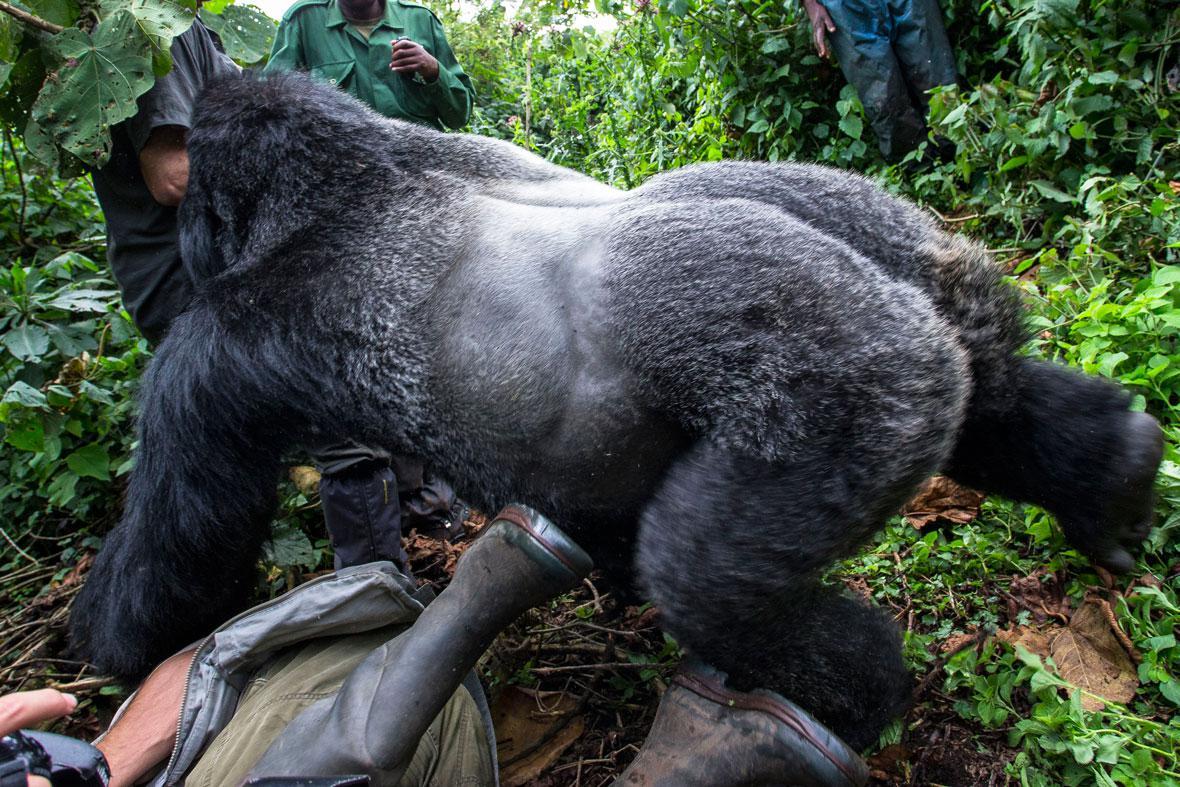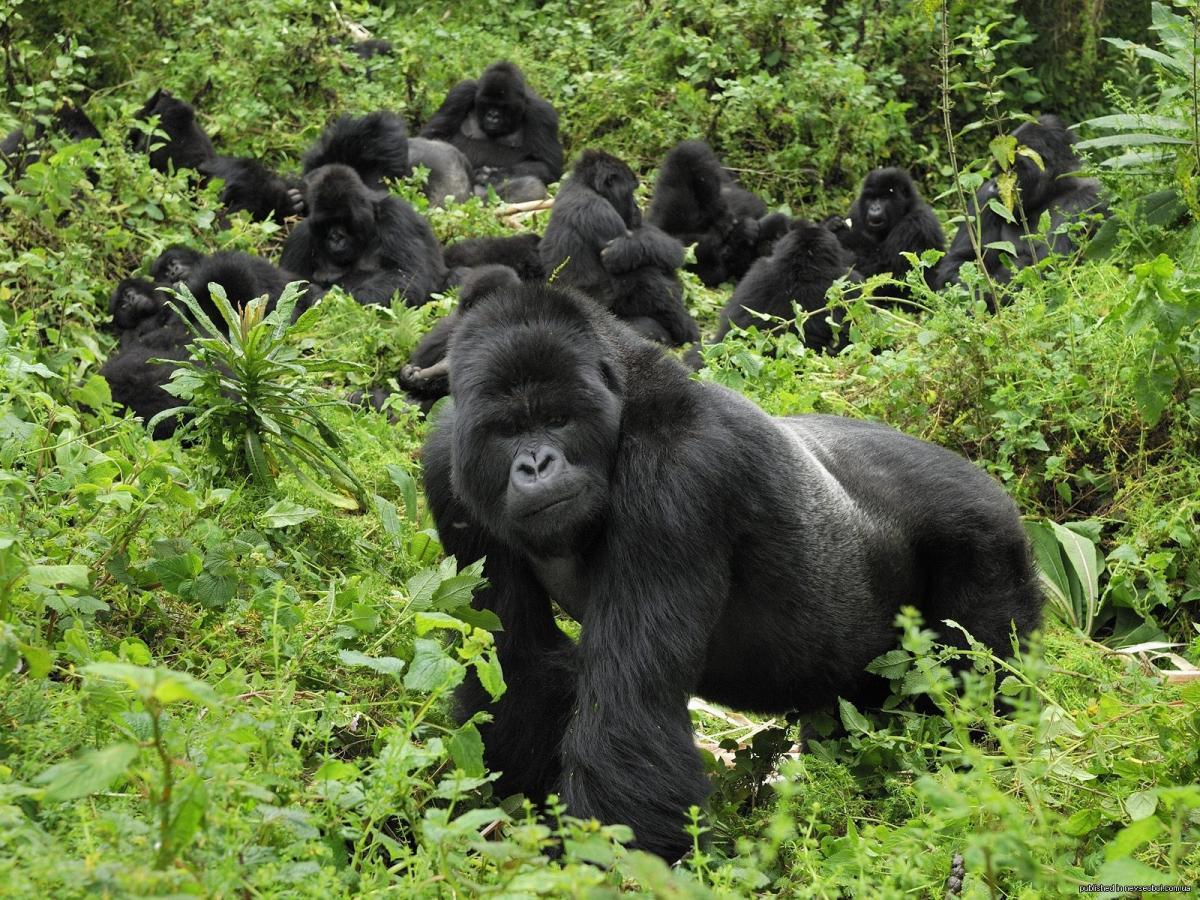The first image is the image on the left, the second image is the image on the right. For the images displayed, is the sentence "There are at least two men in the image with one silverback gorilla." factually correct? Answer yes or no. Yes. The first image is the image on the left, the second image is the image on the right. For the images shown, is this caption "The right image includes an adult gorilla on all fours in the foreground, and the left image includes a large gorilla, multiple people, and someone upside down and off their feet." true? Answer yes or no. Yes. 